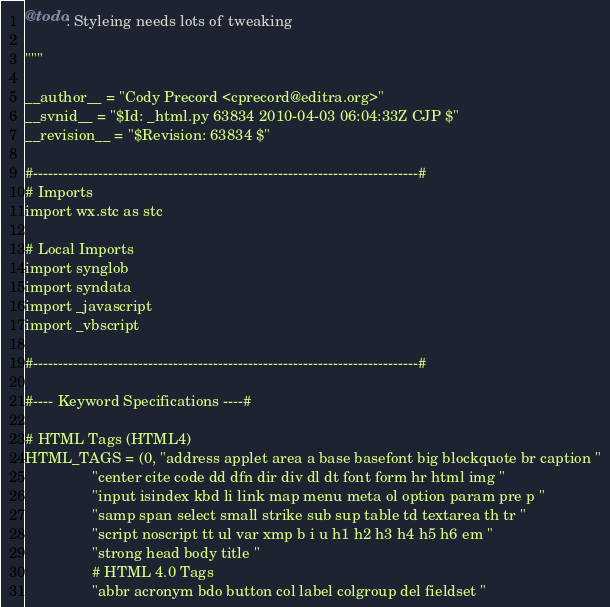Convert code to text. <code><loc_0><loc_0><loc_500><loc_500><_Python_>@todo: Styleing needs lots of tweaking

"""

__author__ = "Cody Precord <cprecord@editra.org>"
__svnid__ = "$Id: _html.py 63834 2010-04-03 06:04:33Z CJP $"
__revision__ = "$Revision: 63834 $"

#-----------------------------------------------------------------------------#
# Imports
import wx.stc as stc

# Local Imports
import synglob
import syndata
import _javascript
import _vbscript

#-----------------------------------------------------------------------------#

#---- Keyword Specifications ----#

# HTML Tags (HTML4)
HTML_TAGS = (0, "address applet area a base basefont big blockquote br caption "
                "center cite code dd dfn dir div dl dt font form hr html img "
                "input isindex kbd li link map menu meta ol option param pre p "
                "samp span select small strike sub sup table td textarea th tr "
                "script noscript tt ul var xmp b i u h1 h2 h3 h4 h5 h6 em "
                "strong head body title "
                # HTML 4.0 Tags
                "abbr acronym bdo button col label colgroup del fieldset "</code> 